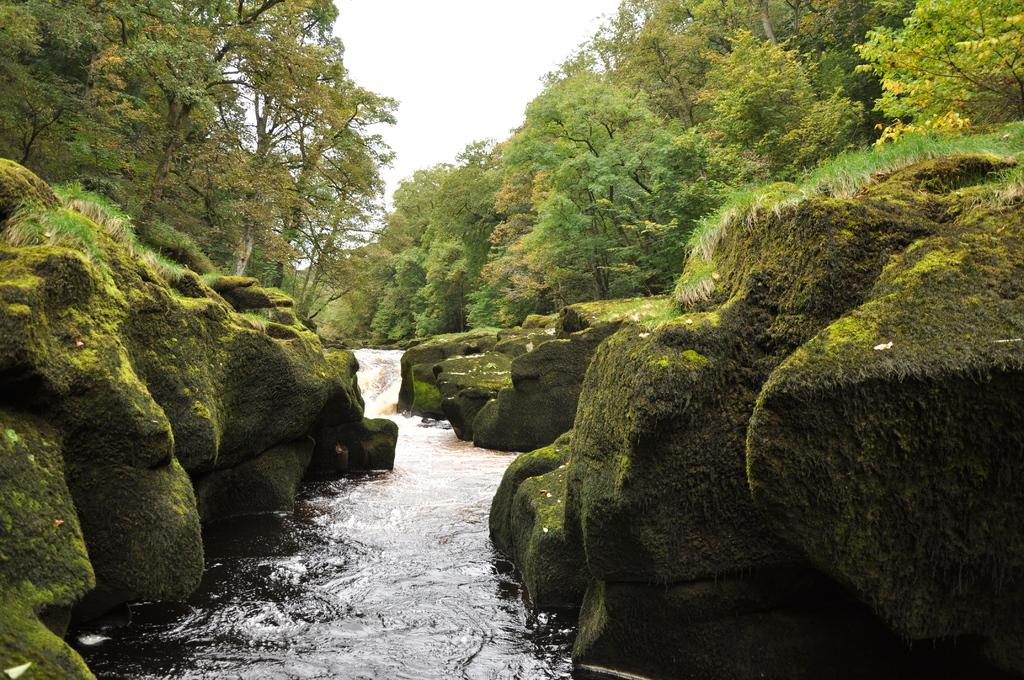What is the main feature in the center of the image? There is a waterfall in the center of the image. What can be seen on the left side of the image? There are hills on the left side of the image. What can be seen on the right side of the image? There are hills on the right side of the image. What type of vegetation is present in the image? There is grass and trees in the image. What is visible at the top of the image? The sky is visible at the top of the image. What type of wine is being served at the waterfall in the image? There is no wine present in the image; it features a waterfall and surrounding landscape. How many robins can be seen perched on the trees in the image? There are no robins present in the image; it only features trees and other vegetation. 